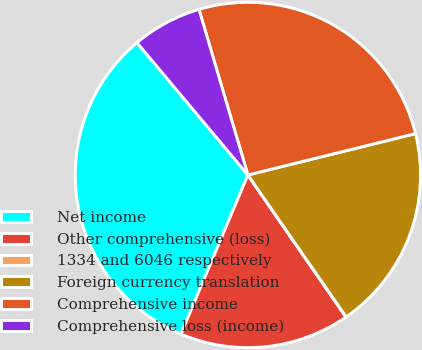Convert chart. <chart><loc_0><loc_0><loc_500><loc_500><pie_chart><fcel>Net income<fcel>Other comprehensive (loss)<fcel>1334 and 6046 respectively<fcel>Foreign currency translation<fcel>Comprehensive income<fcel>Comprehensive loss (income)<nl><fcel>32.56%<fcel>15.96%<fcel>0.02%<fcel>19.21%<fcel>25.72%<fcel>6.53%<nl></chart> 